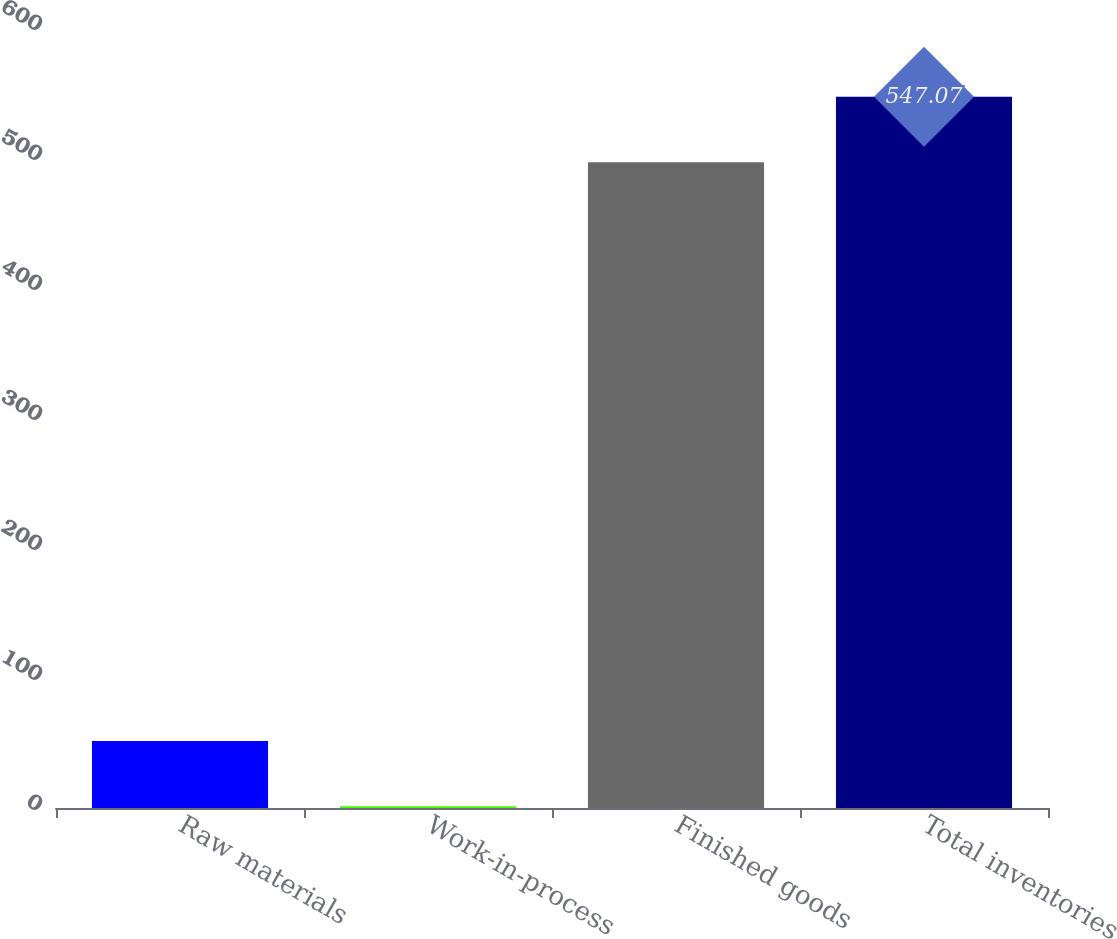<chart> <loc_0><loc_0><loc_500><loc_500><bar_chart><fcel>Raw materials<fcel>Work-in-process<fcel>Finished goods<fcel>Total inventories<nl><fcel>51.57<fcel>1.3<fcel>496.8<fcel>547.07<nl></chart> 